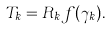<formula> <loc_0><loc_0><loc_500><loc_500>T _ { k } = R _ { k } f ( \gamma _ { k } ) .</formula> 